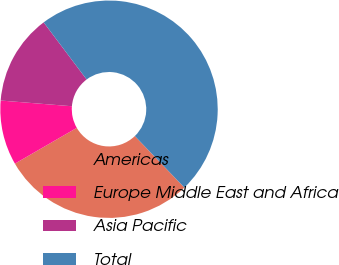<chart> <loc_0><loc_0><loc_500><loc_500><pie_chart><fcel>Americas<fcel>Europe Middle East and Africa<fcel>Asia Pacific<fcel>Total<nl><fcel>28.85%<fcel>9.62%<fcel>13.46%<fcel>48.08%<nl></chart> 